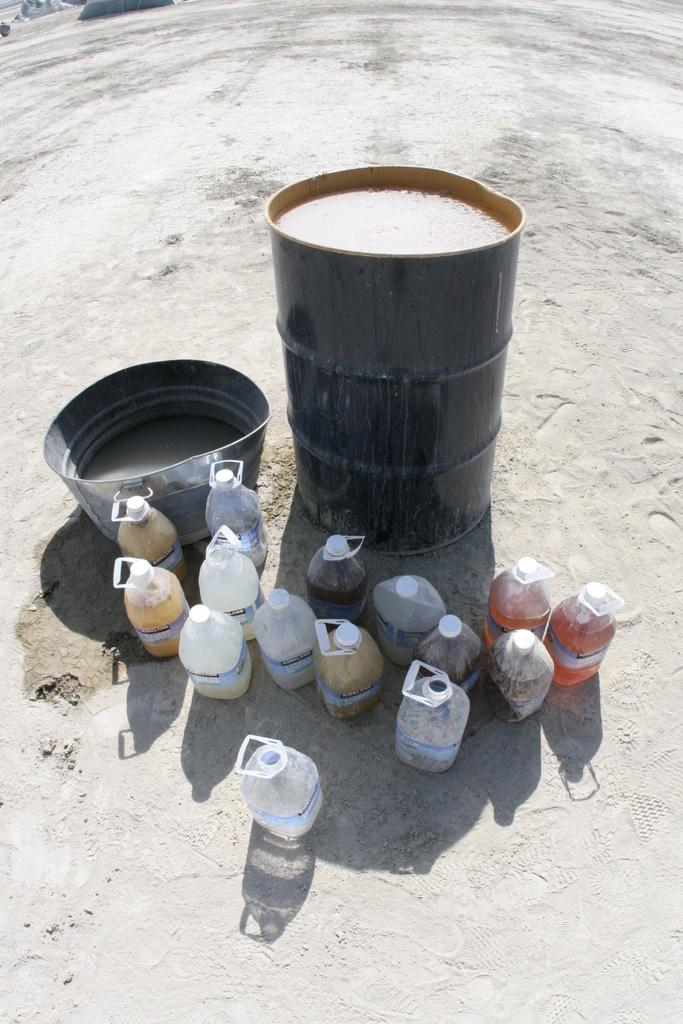What musical instrument is present in the image? There is a drum in the image. What can be found in the tub in the image? There is water in the tub in the image. What type of containers are on the ground in the image? There are bottle cans with liquids on the ground in the image. What type of yarn is being used to create a pattern in the image? There is no yarn present in the image; it features a drum, a tub with water, and bottle cans with liquids. 